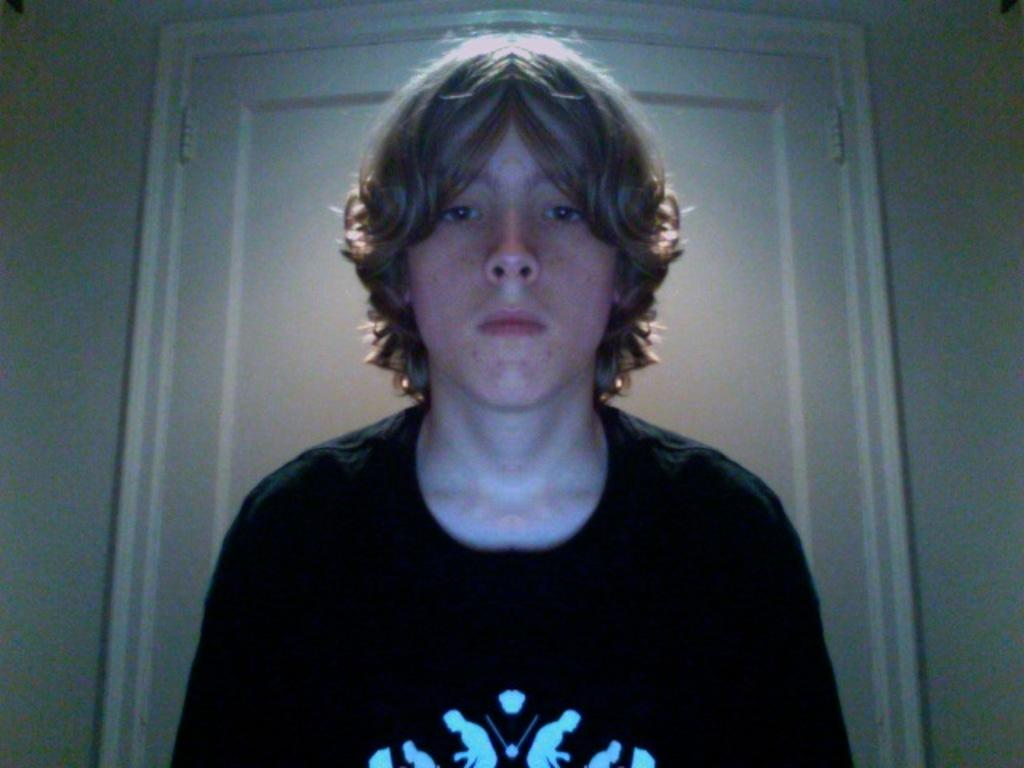Who or what is the main subject in the center of the image? There is a person in the center of the image. What is the person wearing? The person is wearing a black shirt. What can be seen in the background of the image? There is a door and a wall in the background of the image. Can you tell me how many times the person kicks the ear in the image? There is no ear or kicking action present in the image. 